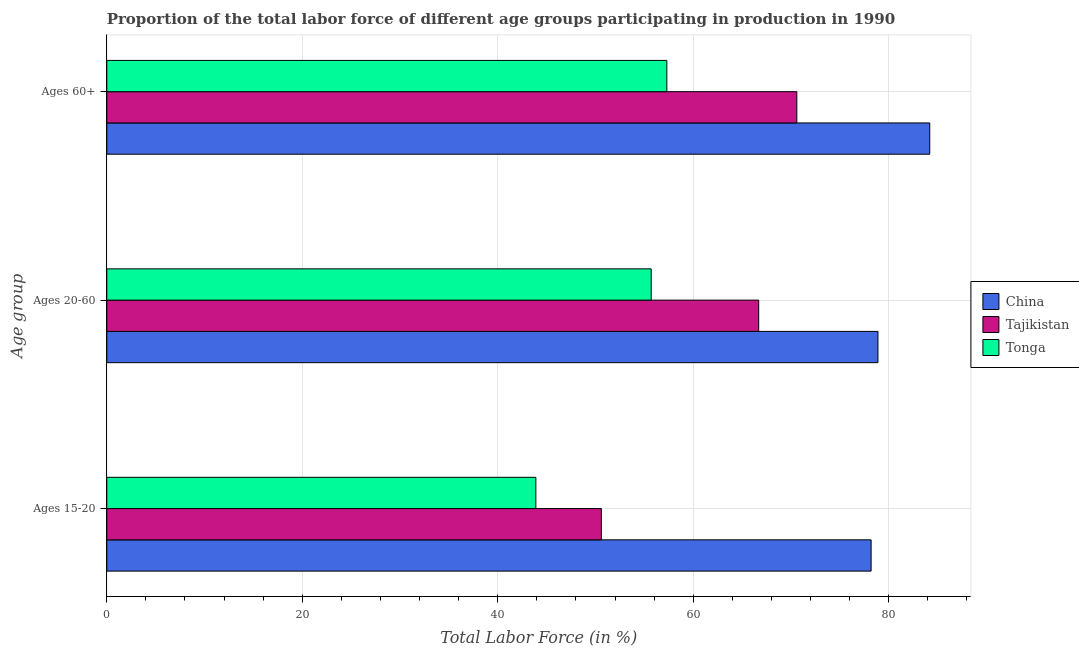How many bars are there on the 1st tick from the bottom?
Your response must be concise. 3. What is the label of the 2nd group of bars from the top?
Your answer should be very brief. Ages 20-60. What is the percentage of labor force within the age group 15-20 in Tajikistan?
Offer a terse response. 50.6. Across all countries, what is the maximum percentage of labor force within the age group 15-20?
Provide a succinct answer. 78.2. Across all countries, what is the minimum percentage of labor force within the age group 15-20?
Your answer should be compact. 43.9. In which country was the percentage of labor force above age 60 minimum?
Give a very brief answer. Tonga. What is the total percentage of labor force above age 60 in the graph?
Provide a short and direct response. 212.1. What is the difference between the percentage of labor force within the age group 15-20 in Tonga and that in China?
Give a very brief answer. -34.3. What is the difference between the percentage of labor force above age 60 in China and the percentage of labor force within the age group 15-20 in Tajikistan?
Your answer should be very brief. 33.6. What is the average percentage of labor force above age 60 per country?
Make the answer very short. 70.7. What is the difference between the percentage of labor force above age 60 and percentage of labor force within the age group 15-20 in China?
Provide a short and direct response. 6. What is the ratio of the percentage of labor force within the age group 20-60 in China to that in Tajikistan?
Your response must be concise. 1.18. Is the difference between the percentage of labor force within the age group 15-20 in Tajikistan and Tonga greater than the difference between the percentage of labor force within the age group 20-60 in Tajikistan and Tonga?
Provide a succinct answer. No. What is the difference between the highest and the second highest percentage of labor force within the age group 20-60?
Provide a succinct answer. 12.2. What is the difference between the highest and the lowest percentage of labor force above age 60?
Provide a short and direct response. 26.9. In how many countries, is the percentage of labor force within the age group 20-60 greater than the average percentage of labor force within the age group 20-60 taken over all countries?
Make the answer very short. 1. Is the sum of the percentage of labor force within the age group 20-60 in Tonga and China greater than the maximum percentage of labor force within the age group 15-20 across all countries?
Your answer should be compact. Yes. What does the 1st bar from the bottom in Ages 15-20 represents?
Offer a terse response. China. Are all the bars in the graph horizontal?
Provide a short and direct response. Yes. Are the values on the major ticks of X-axis written in scientific E-notation?
Offer a terse response. No. What is the title of the graph?
Your answer should be compact. Proportion of the total labor force of different age groups participating in production in 1990. Does "Liechtenstein" appear as one of the legend labels in the graph?
Give a very brief answer. No. What is the label or title of the X-axis?
Your answer should be very brief. Total Labor Force (in %). What is the label or title of the Y-axis?
Offer a terse response. Age group. What is the Total Labor Force (in %) in China in Ages 15-20?
Offer a terse response. 78.2. What is the Total Labor Force (in %) of Tajikistan in Ages 15-20?
Offer a terse response. 50.6. What is the Total Labor Force (in %) of Tonga in Ages 15-20?
Provide a short and direct response. 43.9. What is the Total Labor Force (in %) in China in Ages 20-60?
Your response must be concise. 78.9. What is the Total Labor Force (in %) of Tajikistan in Ages 20-60?
Keep it short and to the point. 66.7. What is the Total Labor Force (in %) in Tonga in Ages 20-60?
Offer a terse response. 55.7. What is the Total Labor Force (in %) in China in Ages 60+?
Offer a terse response. 84.2. What is the Total Labor Force (in %) of Tajikistan in Ages 60+?
Offer a very short reply. 70.6. What is the Total Labor Force (in %) of Tonga in Ages 60+?
Offer a very short reply. 57.3. Across all Age group, what is the maximum Total Labor Force (in %) in China?
Offer a terse response. 84.2. Across all Age group, what is the maximum Total Labor Force (in %) in Tajikistan?
Offer a very short reply. 70.6. Across all Age group, what is the maximum Total Labor Force (in %) of Tonga?
Ensure brevity in your answer.  57.3. Across all Age group, what is the minimum Total Labor Force (in %) of China?
Make the answer very short. 78.2. Across all Age group, what is the minimum Total Labor Force (in %) of Tajikistan?
Give a very brief answer. 50.6. Across all Age group, what is the minimum Total Labor Force (in %) in Tonga?
Make the answer very short. 43.9. What is the total Total Labor Force (in %) of China in the graph?
Provide a succinct answer. 241.3. What is the total Total Labor Force (in %) of Tajikistan in the graph?
Keep it short and to the point. 187.9. What is the total Total Labor Force (in %) in Tonga in the graph?
Your answer should be compact. 156.9. What is the difference between the Total Labor Force (in %) in China in Ages 15-20 and that in Ages 20-60?
Offer a very short reply. -0.7. What is the difference between the Total Labor Force (in %) of Tajikistan in Ages 15-20 and that in Ages 20-60?
Your answer should be compact. -16.1. What is the difference between the Total Labor Force (in %) of Tonga in Ages 15-20 and that in Ages 20-60?
Your answer should be compact. -11.8. What is the difference between the Total Labor Force (in %) of China in Ages 15-20 and the Total Labor Force (in %) of Tajikistan in Ages 20-60?
Offer a very short reply. 11.5. What is the difference between the Total Labor Force (in %) in China in Ages 15-20 and the Total Labor Force (in %) in Tonga in Ages 20-60?
Keep it short and to the point. 22.5. What is the difference between the Total Labor Force (in %) in Tajikistan in Ages 15-20 and the Total Labor Force (in %) in Tonga in Ages 20-60?
Ensure brevity in your answer.  -5.1. What is the difference between the Total Labor Force (in %) of China in Ages 15-20 and the Total Labor Force (in %) of Tajikistan in Ages 60+?
Make the answer very short. 7.6. What is the difference between the Total Labor Force (in %) in China in Ages 15-20 and the Total Labor Force (in %) in Tonga in Ages 60+?
Make the answer very short. 20.9. What is the difference between the Total Labor Force (in %) in Tajikistan in Ages 15-20 and the Total Labor Force (in %) in Tonga in Ages 60+?
Keep it short and to the point. -6.7. What is the difference between the Total Labor Force (in %) of China in Ages 20-60 and the Total Labor Force (in %) of Tajikistan in Ages 60+?
Your answer should be very brief. 8.3. What is the difference between the Total Labor Force (in %) of China in Ages 20-60 and the Total Labor Force (in %) of Tonga in Ages 60+?
Your answer should be compact. 21.6. What is the average Total Labor Force (in %) in China per Age group?
Provide a short and direct response. 80.43. What is the average Total Labor Force (in %) in Tajikistan per Age group?
Provide a succinct answer. 62.63. What is the average Total Labor Force (in %) in Tonga per Age group?
Make the answer very short. 52.3. What is the difference between the Total Labor Force (in %) in China and Total Labor Force (in %) in Tajikistan in Ages 15-20?
Offer a very short reply. 27.6. What is the difference between the Total Labor Force (in %) of China and Total Labor Force (in %) of Tonga in Ages 15-20?
Give a very brief answer. 34.3. What is the difference between the Total Labor Force (in %) of Tajikistan and Total Labor Force (in %) of Tonga in Ages 15-20?
Your answer should be very brief. 6.7. What is the difference between the Total Labor Force (in %) in China and Total Labor Force (in %) in Tonga in Ages 20-60?
Your answer should be compact. 23.2. What is the difference between the Total Labor Force (in %) of Tajikistan and Total Labor Force (in %) of Tonga in Ages 20-60?
Provide a short and direct response. 11. What is the difference between the Total Labor Force (in %) of China and Total Labor Force (in %) of Tajikistan in Ages 60+?
Keep it short and to the point. 13.6. What is the difference between the Total Labor Force (in %) of China and Total Labor Force (in %) of Tonga in Ages 60+?
Ensure brevity in your answer.  26.9. What is the difference between the Total Labor Force (in %) of Tajikistan and Total Labor Force (in %) of Tonga in Ages 60+?
Offer a terse response. 13.3. What is the ratio of the Total Labor Force (in %) of China in Ages 15-20 to that in Ages 20-60?
Provide a short and direct response. 0.99. What is the ratio of the Total Labor Force (in %) in Tajikistan in Ages 15-20 to that in Ages 20-60?
Your answer should be very brief. 0.76. What is the ratio of the Total Labor Force (in %) of Tonga in Ages 15-20 to that in Ages 20-60?
Offer a very short reply. 0.79. What is the ratio of the Total Labor Force (in %) in China in Ages 15-20 to that in Ages 60+?
Give a very brief answer. 0.93. What is the ratio of the Total Labor Force (in %) of Tajikistan in Ages 15-20 to that in Ages 60+?
Make the answer very short. 0.72. What is the ratio of the Total Labor Force (in %) in Tonga in Ages 15-20 to that in Ages 60+?
Offer a very short reply. 0.77. What is the ratio of the Total Labor Force (in %) of China in Ages 20-60 to that in Ages 60+?
Provide a succinct answer. 0.94. What is the ratio of the Total Labor Force (in %) of Tajikistan in Ages 20-60 to that in Ages 60+?
Offer a terse response. 0.94. What is the ratio of the Total Labor Force (in %) of Tonga in Ages 20-60 to that in Ages 60+?
Provide a short and direct response. 0.97. What is the difference between the highest and the second highest Total Labor Force (in %) in China?
Your answer should be very brief. 5.3. What is the difference between the highest and the second highest Total Labor Force (in %) of Tajikistan?
Your answer should be very brief. 3.9. What is the difference between the highest and the lowest Total Labor Force (in %) of China?
Provide a succinct answer. 6. 